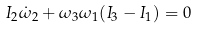<formula> <loc_0><loc_0><loc_500><loc_500>I _ { 2 } \dot { \omega } _ { 2 } + \omega _ { 3 } \omega _ { 1 } ( I _ { 3 } - I _ { 1 } ) = 0</formula> 